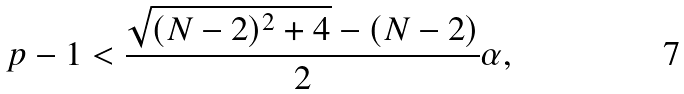Convert formula to latex. <formula><loc_0><loc_0><loc_500><loc_500>p - 1 < \frac { \sqrt { ( N - 2 ) ^ { 2 } + 4 } - ( N - 2 ) } { 2 } \alpha ,</formula> 